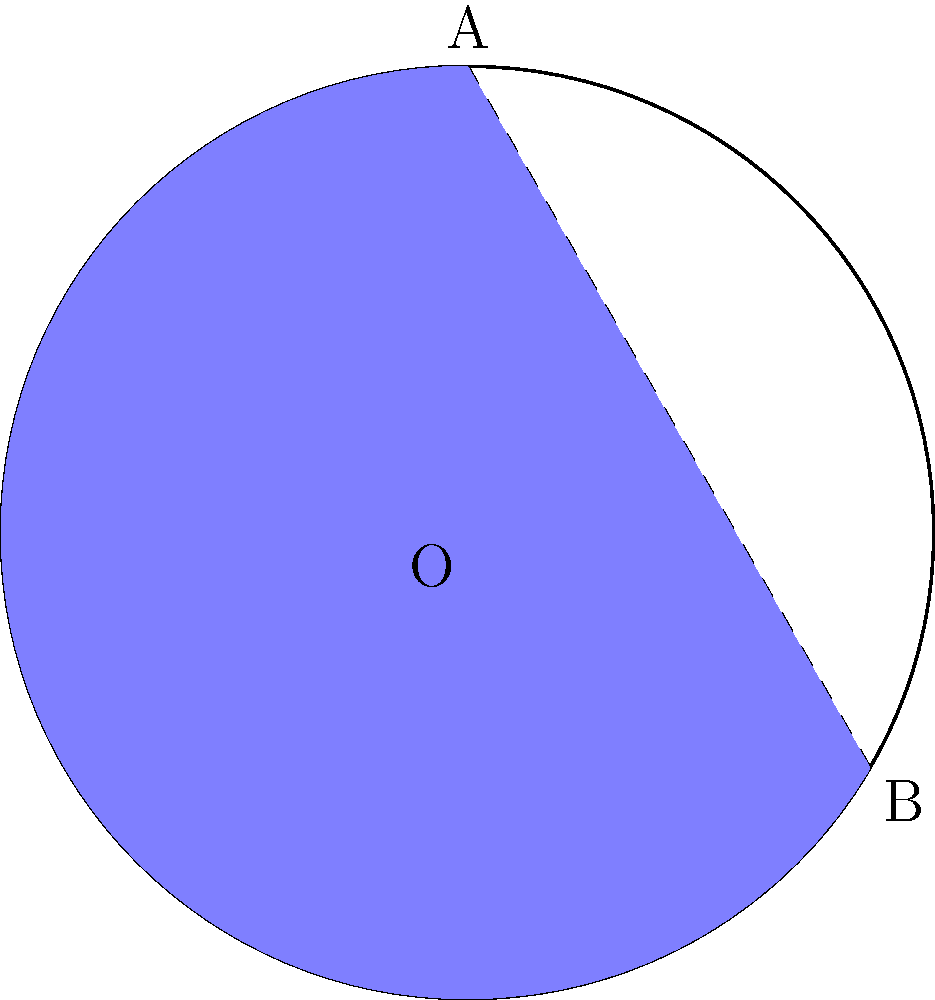A circular reservoir for a hydroelectric power plant is represented by the blue segment in the diagram. If the radius of the reservoir is 500 meters and the central angle $\theta$ is 2.1 radians, calculate the area of the reservoir in square kilometers. Round your answer to two decimal places. To find the area of the circular segment, we need to follow these steps:

1) The area of a circular segment is given by the formula:
   $$A = r^2 (\theta - \sin\theta)$$
   where $r$ is the radius and $\theta$ is the central angle in radians.

2) We're given:
   $r = 500$ meters
   $\theta = 2.1$ radians

3) Let's substitute these values into the formula:
   $$A = 500^2 (2.1 - \sin(2.1))$$

4) Calculate $\sin(2.1)$:
   $\sin(2.1) \approx 0.8632$

5) Now we can calculate:
   $$A = 250000 (2.1 - 0.8632)$$
   $$A = 250000 \times 1.2368$$
   $$A = 309200 \text{ square meters}$$

6) Convert to square kilometers:
   $$309200 \text{ m}^2 = 0.3092 \text{ km}^2$$

7) Rounding to two decimal places:
   $$A \approx 0.31 \text{ km}^2$$
Answer: 0.31 km² 